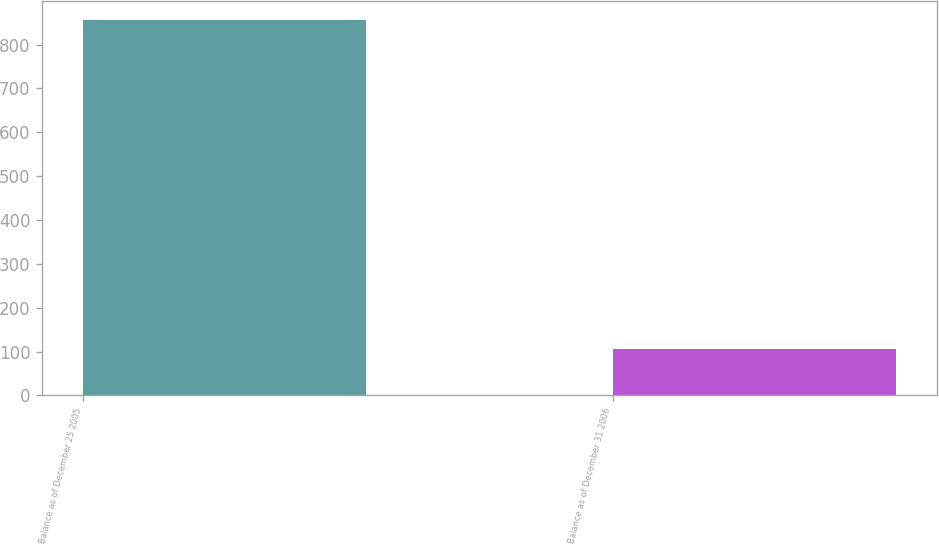<chart> <loc_0><loc_0><loc_500><loc_500><bar_chart><fcel>Balance as of December 25 2005<fcel>Balance as of December 31 2006<nl><fcel>857<fcel>105<nl></chart> 